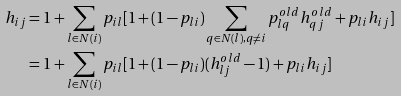Convert formula to latex. <formula><loc_0><loc_0><loc_500><loc_500>h _ { i j } & = 1 + \sum _ { l \in N ( i ) } p _ { i l } [ 1 + ( 1 - p _ { l i } ) \sum _ { q \in N ( l ) , q \neq i } p _ { l q } ^ { o l d } h _ { q j } ^ { o l d } + p _ { l i } h _ { i j } ] \\ & = 1 + \sum _ { l \in N ( i ) } p _ { i l } [ 1 + ( 1 - p _ { l i } ) ( h _ { l j } ^ { o l d } - 1 ) + p _ { l i } h _ { i j } ]</formula> 